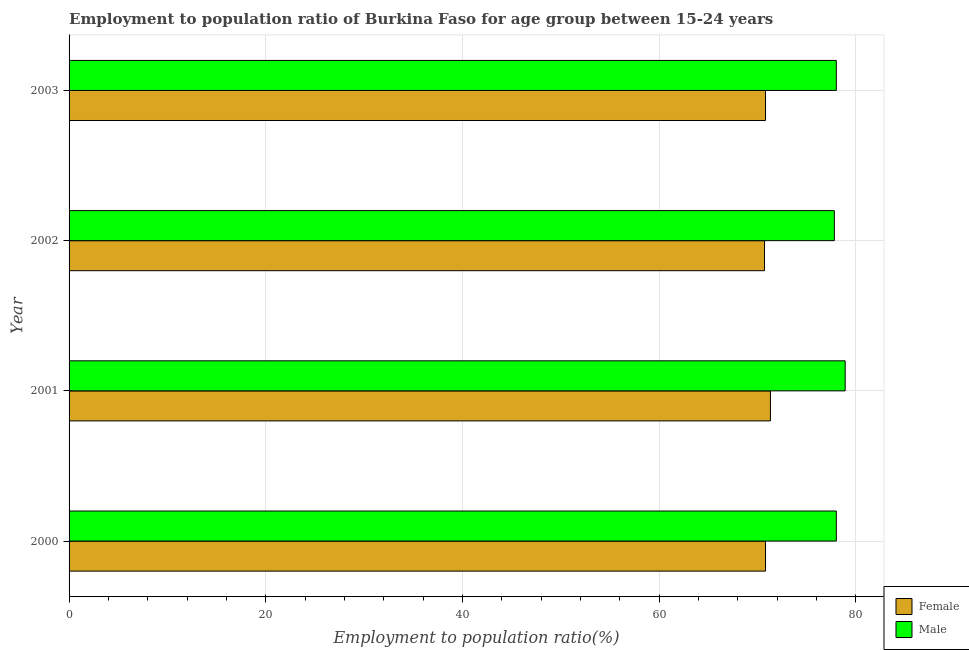Are the number of bars per tick equal to the number of legend labels?
Make the answer very short. Yes. How many bars are there on the 2nd tick from the top?
Your answer should be compact. 2. What is the employment to population ratio(female) in 2002?
Make the answer very short. 70.7. Across all years, what is the maximum employment to population ratio(male)?
Provide a short and direct response. 78.9. Across all years, what is the minimum employment to population ratio(male)?
Keep it short and to the point. 77.8. In which year was the employment to population ratio(male) minimum?
Provide a succinct answer. 2002. What is the total employment to population ratio(male) in the graph?
Offer a very short reply. 312.7. What is the average employment to population ratio(male) per year?
Your response must be concise. 78.17. What is the ratio of the employment to population ratio(male) in 2001 to that in 2002?
Make the answer very short. 1.01. Is the difference between the employment to population ratio(female) in 2000 and 2001 greater than the difference between the employment to population ratio(male) in 2000 and 2001?
Offer a very short reply. Yes. What is the difference between the highest and the second highest employment to population ratio(male)?
Your response must be concise. 0.9. Is the sum of the employment to population ratio(female) in 2000 and 2003 greater than the maximum employment to population ratio(male) across all years?
Offer a terse response. Yes. What does the 2nd bar from the top in 2000 represents?
Ensure brevity in your answer.  Female. How many years are there in the graph?
Provide a succinct answer. 4. Does the graph contain any zero values?
Provide a short and direct response. No. Where does the legend appear in the graph?
Offer a terse response. Bottom right. How many legend labels are there?
Your answer should be very brief. 2. How are the legend labels stacked?
Provide a short and direct response. Vertical. What is the title of the graph?
Keep it short and to the point. Employment to population ratio of Burkina Faso for age group between 15-24 years. Does "Manufacturing industries and construction" appear as one of the legend labels in the graph?
Keep it short and to the point. No. What is the Employment to population ratio(%) of Female in 2000?
Your answer should be compact. 70.8. What is the Employment to population ratio(%) in Male in 2000?
Your answer should be very brief. 78. What is the Employment to population ratio(%) in Female in 2001?
Give a very brief answer. 71.3. What is the Employment to population ratio(%) in Male in 2001?
Give a very brief answer. 78.9. What is the Employment to population ratio(%) in Female in 2002?
Your response must be concise. 70.7. What is the Employment to population ratio(%) in Male in 2002?
Give a very brief answer. 77.8. What is the Employment to population ratio(%) in Female in 2003?
Offer a very short reply. 70.8. Across all years, what is the maximum Employment to population ratio(%) in Female?
Your response must be concise. 71.3. Across all years, what is the maximum Employment to population ratio(%) in Male?
Your response must be concise. 78.9. Across all years, what is the minimum Employment to population ratio(%) in Female?
Your answer should be compact. 70.7. Across all years, what is the minimum Employment to population ratio(%) of Male?
Provide a succinct answer. 77.8. What is the total Employment to population ratio(%) in Female in the graph?
Your answer should be very brief. 283.6. What is the total Employment to population ratio(%) of Male in the graph?
Offer a very short reply. 312.7. What is the difference between the Employment to population ratio(%) in Female in 2000 and that in 2001?
Provide a short and direct response. -0.5. What is the difference between the Employment to population ratio(%) in Female in 2000 and that in 2002?
Keep it short and to the point. 0.1. What is the difference between the Employment to population ratio(%) of Female in 2001 and that in 2003?
Your answer should be very brief. 0.5. What is the difference between the Employment to population ratio(%) in Female in 2000 and the Employment to population ratio(%) in Male in 2002?
Make the answer very short. -7. What is the difference between the Employment to population ratio(%) of Female in 2000 and the Employment to population ratio(%) of Male in 2003?
Provide a short and direct response. -7.2. What is the difference between the Employment to population ratio(%) in Female in 2001 and the Employment to population ratio(%) in Male in 2002?
Make the answer very short. -6.5. What is the average Employment to population ratio(%) of Female per year?
Give a very brief answer. 70.9. What is the average Employment to population ratio(%) in Male per year?
Offer a very short reply. 78.17. In the year 2001, what is the difference between the Employment to population ratio(%) of Female and Employment to population ratio(%) of Male?
Ensure brevity in your answer.  -7.6. In the year 2002, what is the difference between the Employment to population ratio(%) of Female and Employment to population ratio(%) of Male?
Provide a short and direct response. -7.1. What is the ratio of the Employment to population ratio(%) of Female in 2000 to that in 2001?
Provide a succinct answer. 0.99. What is the ratio of the Employment to population ratio(%) of Female in 2000 to that in 2002?
Give a very brief answer. 1. What is the ratio of the Employment to population ratio(%) of Male in 2000 to that in 2002?
Offer a terse response. 1. What is the ratio of the Employment to population ratio(%) of Female in 2000 to that in 2003?
Your answer should be very brief. 1. What is the ratio of the Employment to population ratio(%) in Female in 2001 to that in 2002?
Give a very brief answer. 1.01. What is the ratio of the Employment to population ratio(%) in Male in 2001 to that in 2002?
Provide a succinct answer. 1.01. What is the ratio of the Employment to population ratio(%) in Female in 2001 to that in 2003?
Offer a very short reply. 1.01. What is the ratio of the Employment to population ratio(%) in Male in 2001 to that in 2003?
Your answer should be very brief. 1.01. What is the ratio of the Employment to population ratio(%) of Female in 2002 to that in 2003?
Provide a succinct answer. 1. What is the ratio of the Employment to population ratio(%) of Male in 2002 to that in 2003?
Offer a very short reply. 1. What is the difference between the highest and the second highest Employment to population ratio(%) in Female?
Provide a succinct answer. 0.5. What is the difference between the highest and the lowest Employment to population ratio(%) in Male?
Ensure brevity in your answer.  1.1. 